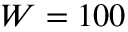<formula> <loc_0><loc_0><loc_500><loc_500>W = 1 0 0</formula> 